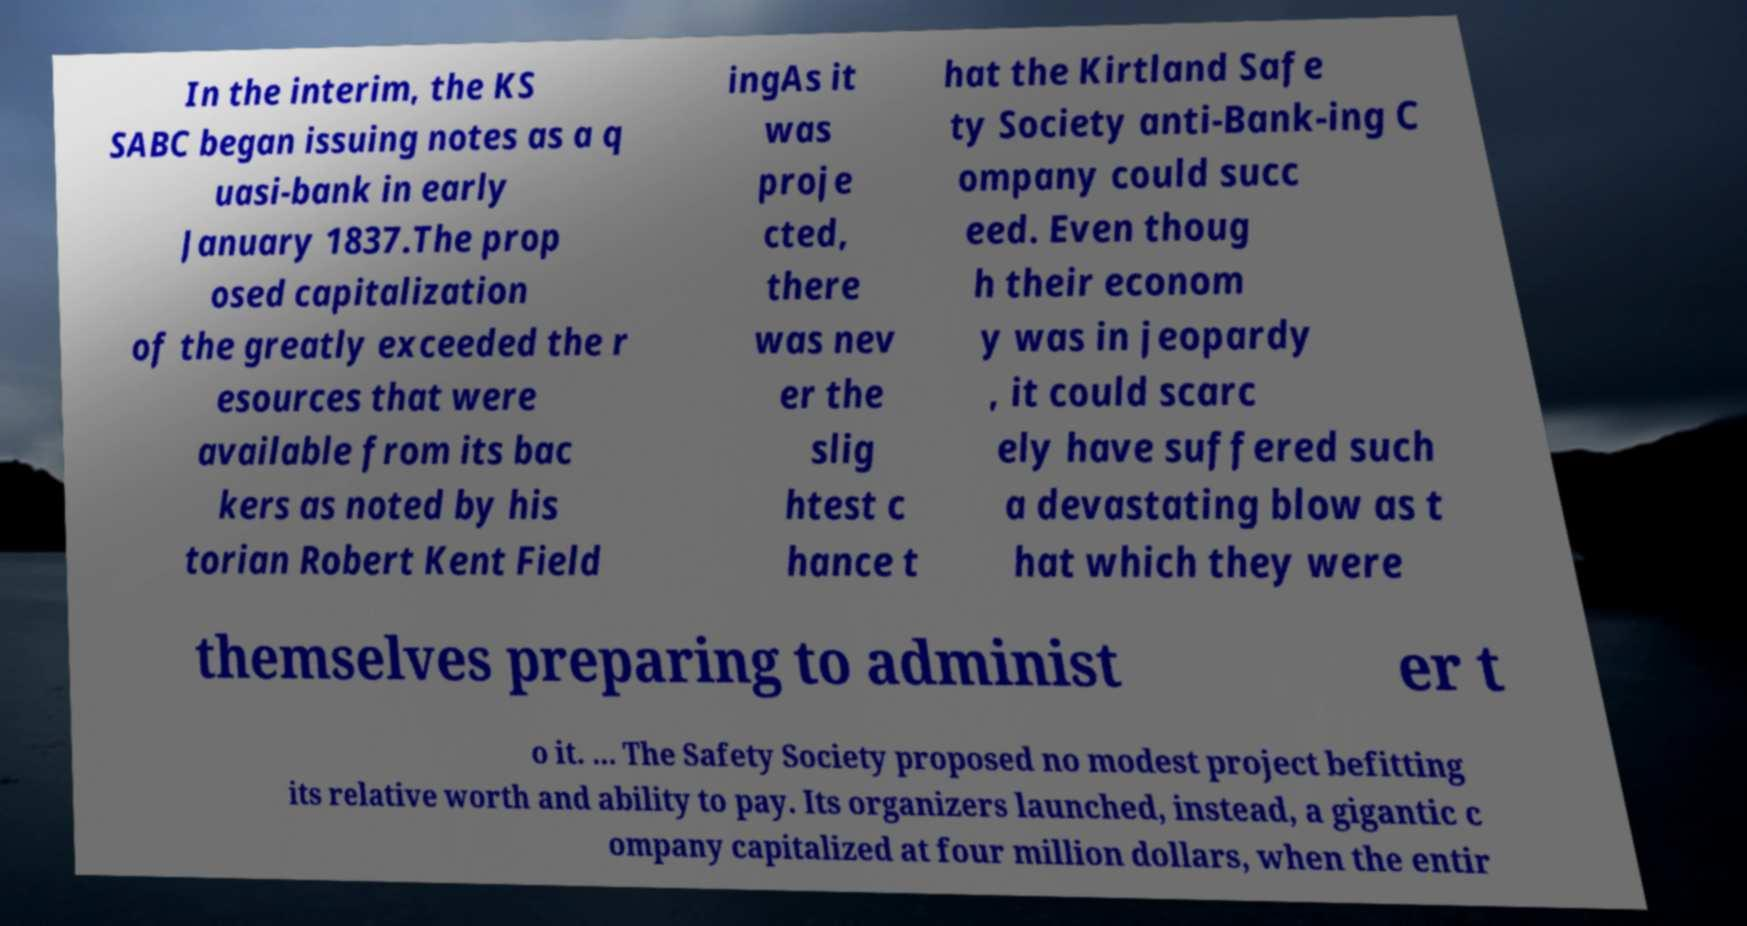I need the written content from this picture converted into text. Can you do that? In the interim, the KS SABC began issuing notes as a q uasi-bank in early January 1837.The prop osed capitalization of the greatly exceeded the r esources that were available from its bac kers as noted by his torian Robert Kent Field ingAs it was proje cted, there was nev er the slig htest c hance t hat the Kirtland Safe ty Society anti-Bank-ing C ompany could succ eed. Even thoug h their econom y was in jeopardy , it could scarc ely have suffered such a devastating blow as t hat which they were themselves preparing to administ er t o it. ... The Safety Society proposed no modest project befitting its relative worth and ability to pay. Its organizers launched, instead, a gigantic c ompany capitalized at four million dollars, when the entir 